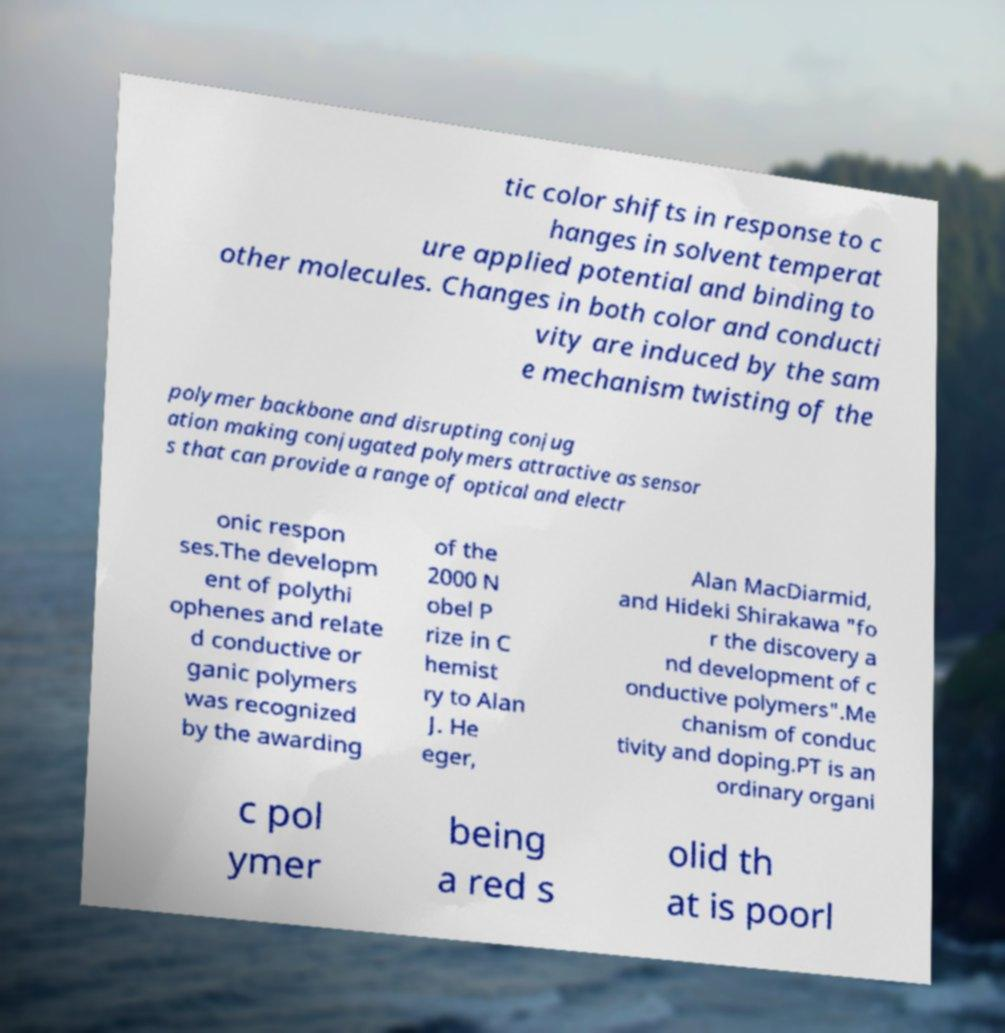Please identify and transcribe the text found in this image. tic color shifts in response to c hanges in solvent temperat ure applied potential and binding to other molecules. Changes in both color and conducti vity are induced by the sam e mechanism twisting of the polymer backbone and disrupting conjug ation making conjugated polymers attractive as sensor s that can provide a range of optical and electr onic respon ses.The developm ent of polythi ophenes and relate d conductive or ganic polymers was recognized by the awarding of the 2000 N obel P rize in C hemist ry to Alan J. He eger, Alan MacDiarmid, and Hideki Shirakawa "fo r the discovery a nd development of c onductive polymers".Me chanism of conduc tivity and doping.PT is an ordinary organi c pol ymer being a red s olid th at is poorl 